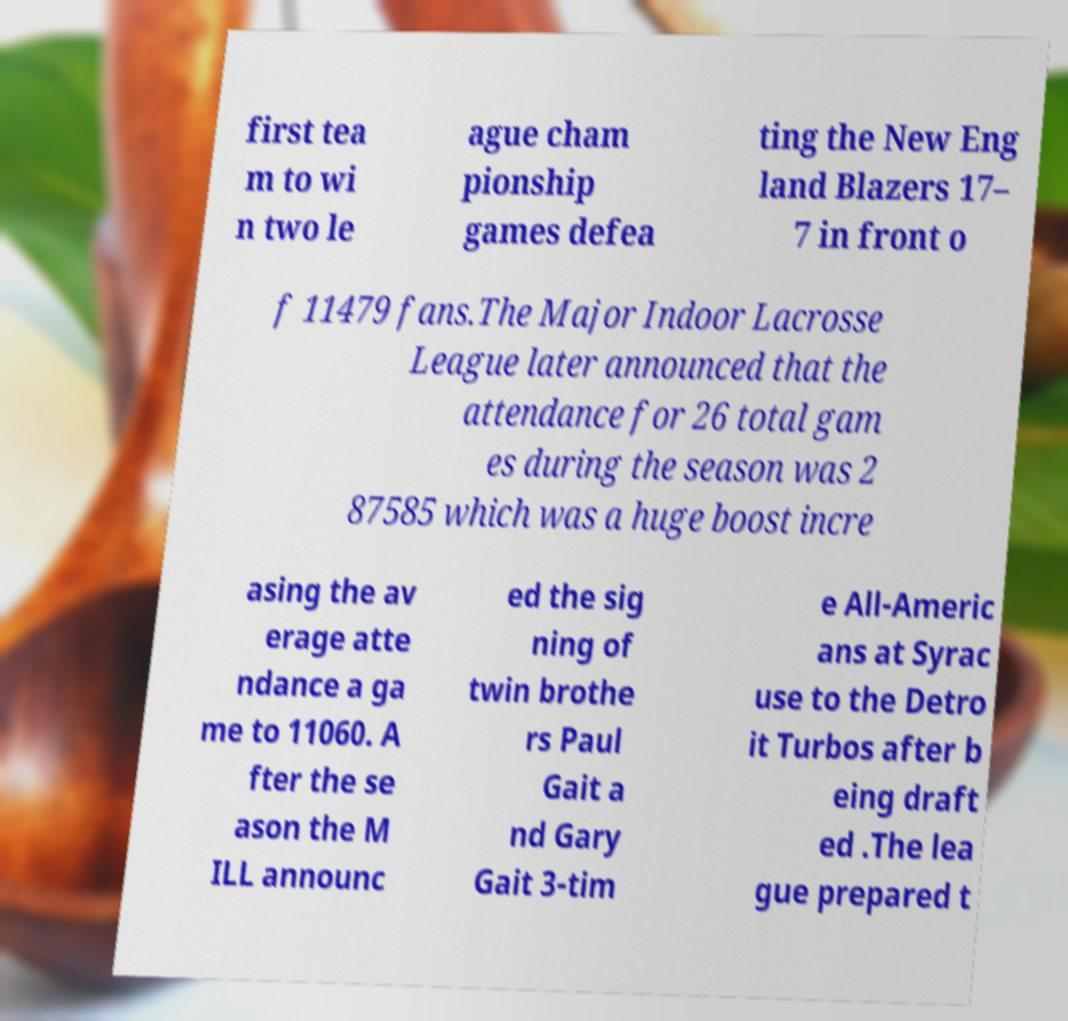Please identify and transcribe the text found in this image. first tea m to wi n two le ague cham pionship games defea ting the New Eng land Blazers 17– 7 in front o f 11479 fans.The Major Indoor Lacrosse League later announced that the attendance for 26 total gam es during the season was 2 87585 which was a huge boost incre asing the av erage atte ndance a ga me to 11060. A fter the se ason the M ILL announc ed the sig ning of twin brothe rs Paul Gait a nd Gary Gait 3-tim e All-Americ ans at Syrac use to the Detro it Turbos after b eing draft ed .The lea gue prepared t 